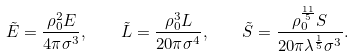<formula> <loc_0><loc_0><loc_500><loc_500>\tilde { E } = \frac { \rho _ { 0 } ^ { 2 } E } { 4 \pi \sigma ^ { 3 } } , \quad \tilde { L } = \frac { \rho _ { 0 } ^ { 3 } L } { 2 0 \pi \sigma ^ { 4 } } , \quad \tilde { S } = \frac { \rho _ { 0 } ^ { \frac { 1 1 } { 5 } } S } { 2 0 \pi \lambda ^ { \frac { 1 } { 5 } } \sigma ^ { 3 } } .</formula> 